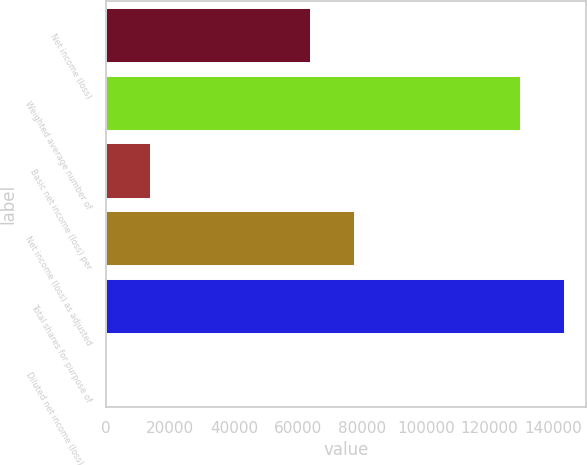<chart> <loc_0><loc_0><loc_500><loc_500><bar_chart><fcel>Net income (loss)<fcel>Weighted average number of<fcel>Basic net income (loss) per<fcel>Net income (loss) as adjusted<fcel>Total shares for purpose of<fcel>Diluted net income (loss) per<nl><fcel>63936<fcel>129474<fcel>13647.8<fcel>77583.4<fcel>143121<fcel>0.47<nl></chart> 